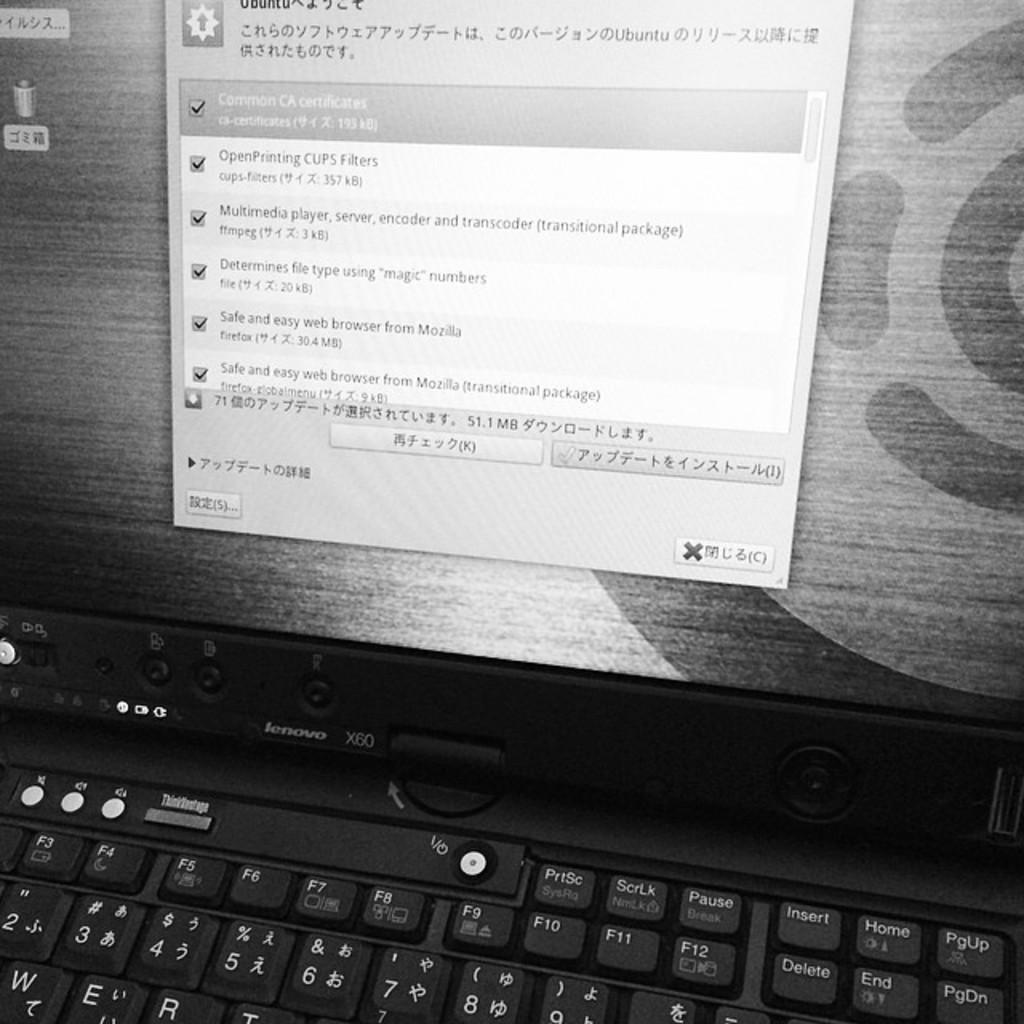Provide a one-sentence caption for the provided image. A laptop screen with asian text on it including "Safe and easy web browser from Mozilla.". 